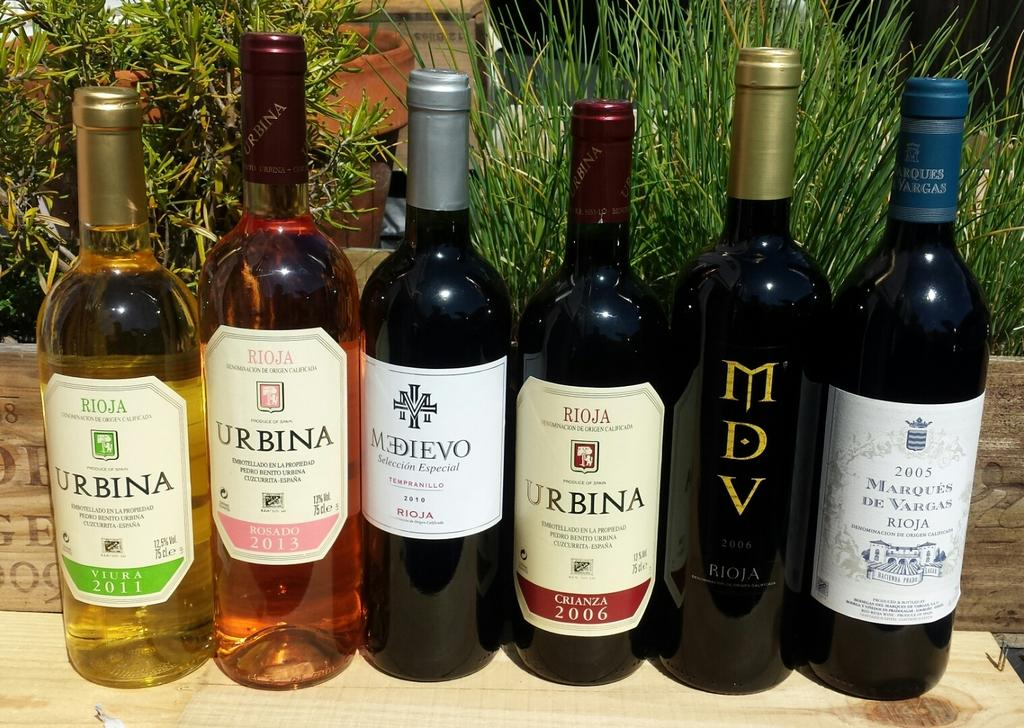<image>
Render a clear and concise summary of the photo. Among the six wine bottles are three from Urbina Vineyards. 